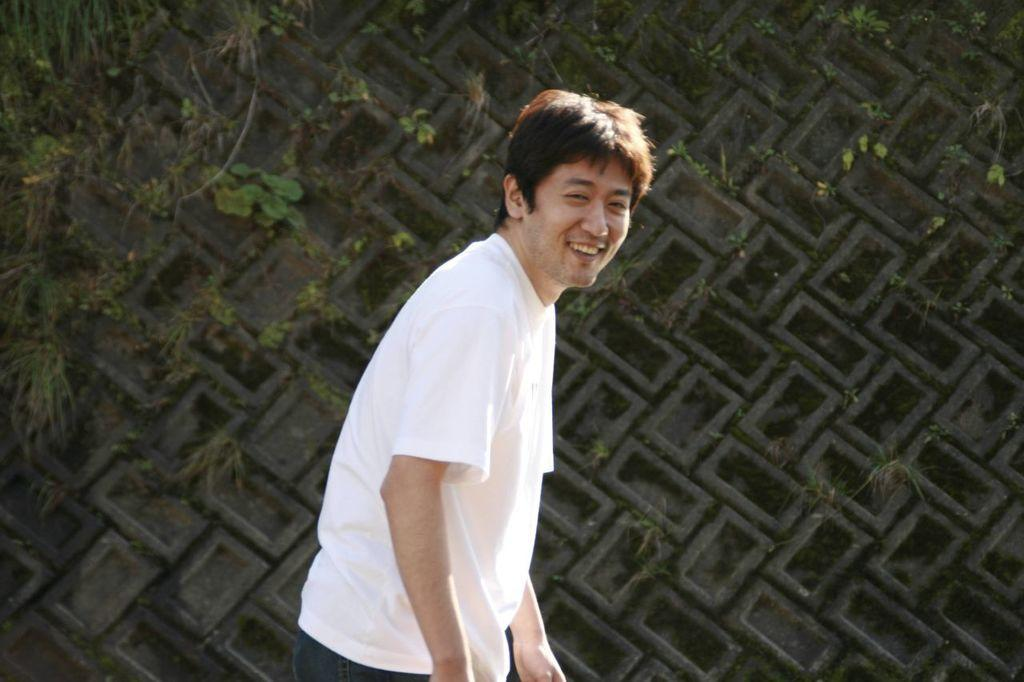Who is the main subject in the image? There is a person in the center of the image. What is the person doing in the image? The person is smiling. What can be seen in the background of the image? There is a tree and a wall in the background of the image. What type of lumber is the person using to build a treehouse in the image? There is no lumber or treehouse present in the image; it features a person smiling in the center and a tree and a wall in the background. Who is the friend of the person in the image? There is no friend present in the image; it only features a single person. 